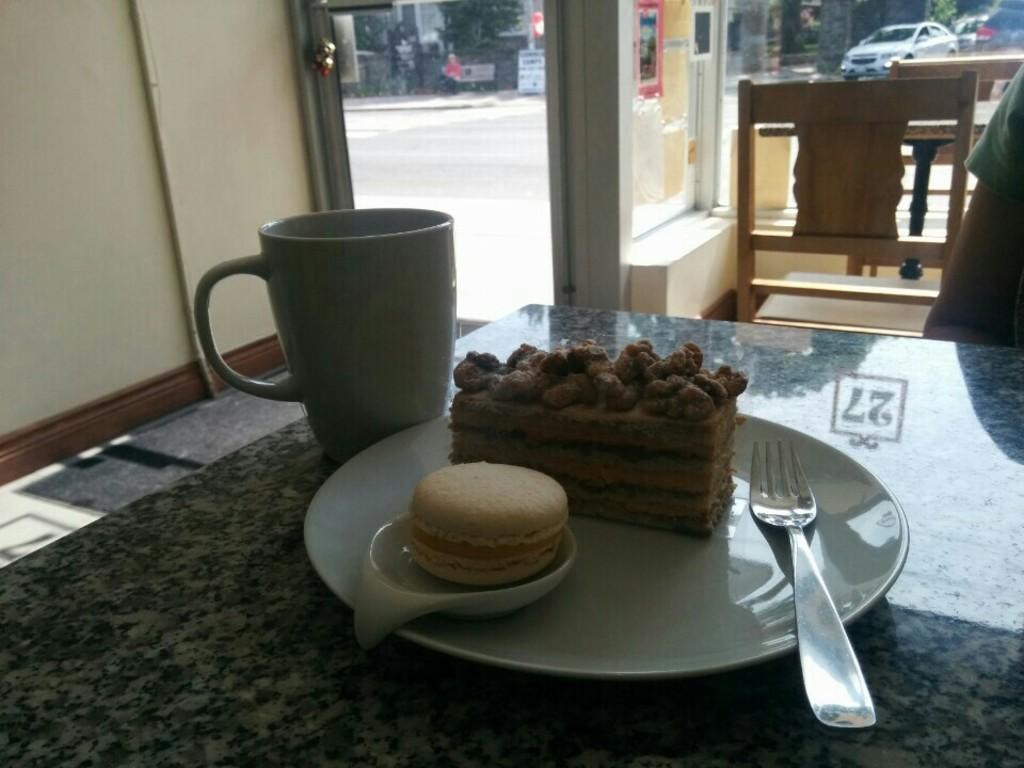Could you give a brief overview of what you see in this image? This is the picture of a table on which there is a plate,jug and a chair and a person in front of the table. 